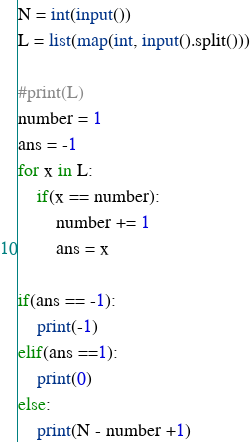<code> <loc_0><loc_0><loc_500><loc_500><_Python_>N = int(input())
L = list(map(int, input().split()))

#print(L)
number = 1
ans = -1
for x in L:
    if(x == number):
        number += 1
        ans = x

if(ans == -1):
    print(-1)
elif(ans ==1):
    print(0)
else:
    print(N - number +1)</code> 